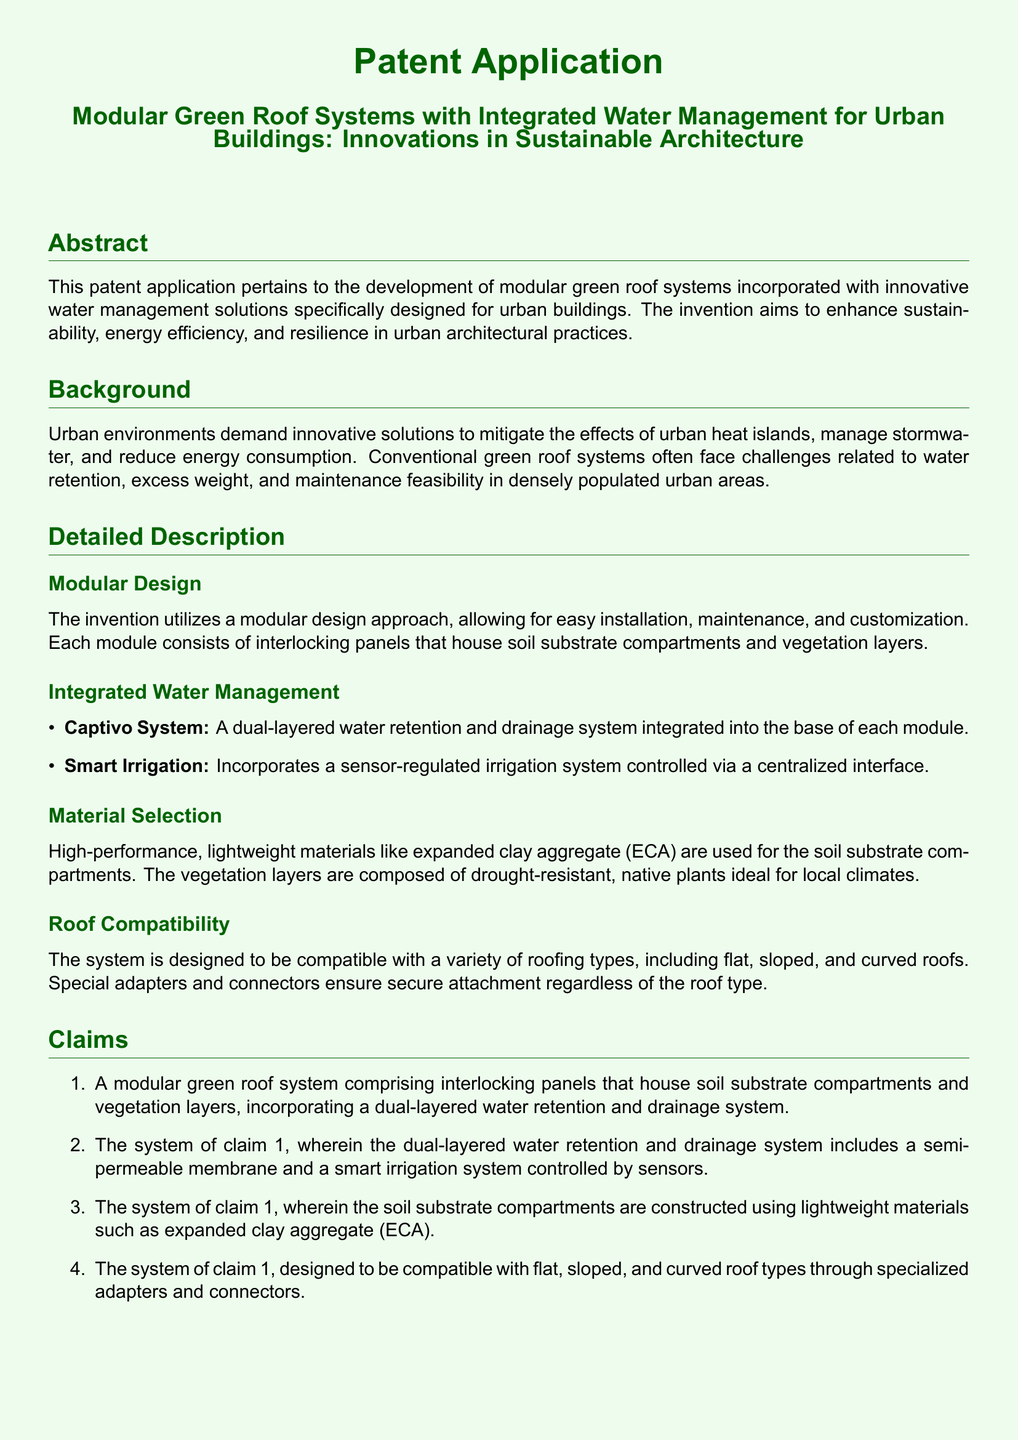what is the title of the patent application? The title of the patent application is presented in the document as a heading.
Answer: Modular Green Roof Systems with Integrated Water Management for Urban Buildings: Innovations in Sustainable Architecture what is the main purpose of the invention? The main purpose of the invention is specified in the abstract section of the document.
Answer: Enhance sustainability, energy efficiency, and resilience in urban architectural practices what materials are used for the soil substrate compartments? The material selection section mentions the specific materials used for the soil substrate compartments.
Answer: Expanded clay aggregate (ECA) how many claims are presented in the patent application? The claims section enumerates the claims made in the patent application.
Answer: Four what roofing types is the system compatible with? The roof compatibility section outlines the types of roofs for which the system is designed.
Answer: Flat, sloped, and curved roofs what does the Captivo System pertain to? The detailed description mentions the Captivo System in relation to water management.
Answer: A dual-layered water retention and drainage system what is the focus of the Integrated Water Management section? The Integrated Water Management section describes the innovations in water management featured in the modular system.
Answer: Water retention and drainage which type of plants are included in the vegetation layers? The material selection section elaborates on the characteristics of the vegetation layers.
Answer: Drought-resistant, native plants 